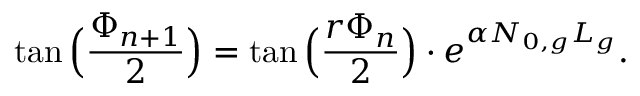Convert formula to latex. <formula><loc_0><loc_0><loc_500><loc_500>\tan \left ( \frac { \Phi _ { n + 1 } } { 2 } \right ) = \tan \left ( \frac { r \Phi _ { n } } { 2 } \right ) \cdot e ^ { \alpha N _ { 0 , g } L _ { g } } .</formula> 